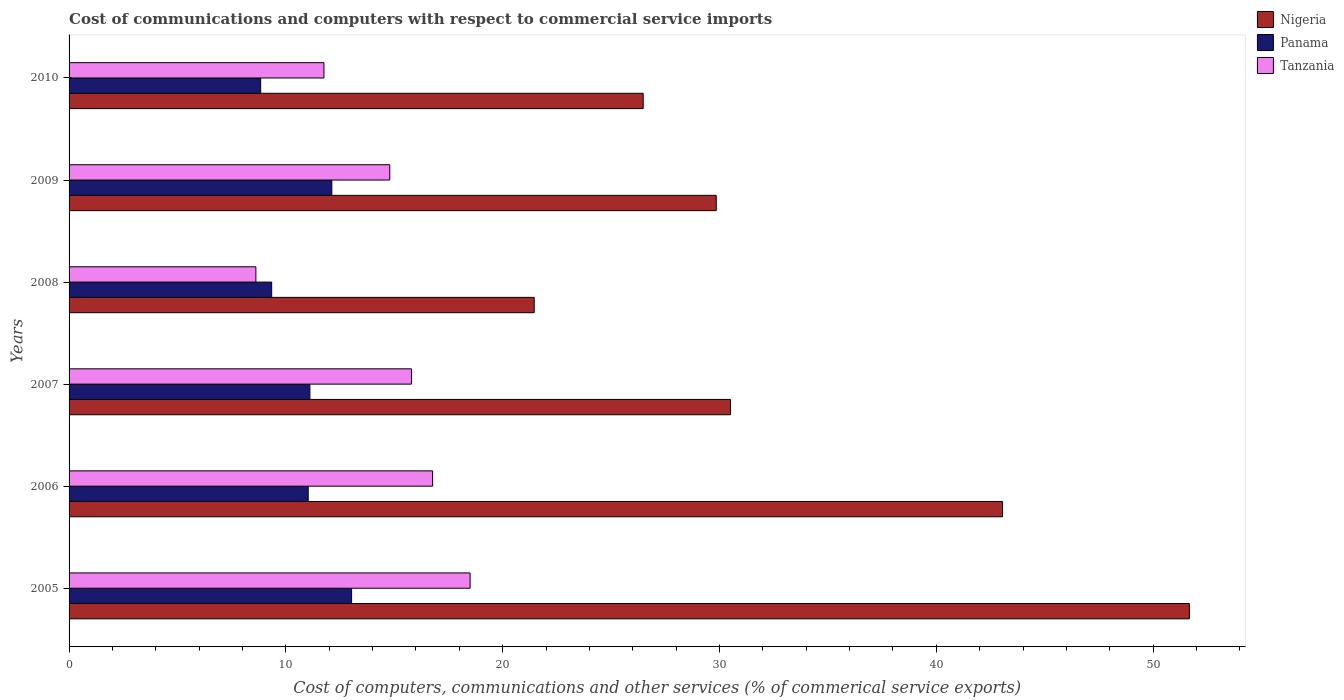How many different coloured bars are there?
Ensure brevity in your answer.  3. How many groups of bars are there?
Your response must be concise. 6. Are the number of bars per tick equal to the number of legend labels?
Provide a short and direct response. Yes. Are the number of bars on each tick of the Y-axis equal?
Make the answer very short. Yes. How many bars are there on the 6th tick from the top?
Your answer should be very brief. 3. How many bars are there on the 3rd tick from the bottom?
Make the answer very short. 3. What is the label of the 3rd group of bars from the top?
Your response must be concise. 2008. What is the cost of communications and computers in Panama in 2008?
Provide a short and direct response. 9.34. Across all years, what is the maximum cost of communications and computers in Tanzania?
Make the answer very short. 18.5. Across all years, what is the minimum cost of communications and computers in Nigeria?
Give a very brief answer. 21.45. In which year was the cost of communications and computers in Panama maximum?
Offer a very short reply. 2005. What is the total cost of communications and computers in Tanzania in the graph?
Give a very brief answer. 86.22. What is the difference between the cost of communications and computers in Panama in 2005 and that in 2007?
Make the answer very short. 1.92. What is the difference between the cost of communications and computers in Tanzania in 2006 and the cost of communications and computers in Panama in 2007?
Give a very brief answer. 5.66. What is the average cost of communications and computers in Nigeria per year?
Your answer should be very brief. 33.83. In the year 2007, what is the difference between the cost of communications and computers in Panama and cost of communications and computers in Nigeria?
Your response must be concise. -19.4. In how many years, is the cost of communications and computers in Panama greater than 20 %?
Give a very brief answer. 0. What is the ratio of the cost of communications and computers in Tanzania in 2006 to that in 2008?
Provide a succinct answer. 1.95. Is the difference between the cost of communications and computers in Panama in 2007 and 2010 greater than the difference between the cost of communications and computers in Nigeria in 2007 and 2010?
Provide a succinct answer. No. What is the difference between the highest and the second highest cost of communications and computers in Nigeria?
Your answer should be very brief. 8.62. What is the difference between the highest and the lowest cost of communications and computers in Panama?
Make the answer very short. 4.19. Is the sum of the cost of communications and computers in Nigeria in 2008 and 2010 greater than the maximum cost of communications and computers in Panama across all years?
Offer a terse response. Yes. What does the 3rd bar from the top in 2005 represents?
Offer a terse response. Nigeria. What does the 2nd bar from the bottom in 2007 represents?
Provide a short and direct response. Panama. Is it the case that in every year, the sum of the cost of communications and computers in Tanzania and cost of communications and computers in Panama is greater than the cost of communications and computers in Nigeria?
Ensure brevity in your answer.  No. How many bars are there?
Make the answer very short. 18. Are all the bars in the graph horizontal?
Provide a short and direct response. Yes. What is the difference between two consecutive major ticks on the X-axis?
Offer a terse response. 10. How are the legend labels stacked?
Provide a succinct answer. Vertical. What is the title of the graph?
Provide a succinct answer. Cost of communications and computers with respect to commercial service imports. What is the label or title of the X-axis?
Your answer should be very brief. Cost of computers, communications and other services (% of commerical service exports). What is the label or title of the Y-axis?
Your answer should be very brief. Years. What is the Cost of computers, communications and other services (% of commerical service exports) in Nigeria in 2005?
Provide a short and direct response. 51.67. What is the Cost of computers, communications and other services (% of commerical service exports) in Panama in 2005?
Provide a succinct answer. 13.03. What is the Cost of computers, communications and other services (% of commerical service exports) of Tanzania in 2005?
Your answer should be very brief. 18.5. What is the Cost of computers, communications and other services (% of commerical service exports) in Nigeria in 2006?
Keep it short and to the point. 43.05. What is the Cost of computers, communications and other services (% of commerical service exports) of Panama in 2006?
Keep it short and to the point. 11.03. What is the Cost of computers, communications and other services (% of commerical service exports) in Tanzania in 2006?
Give a very brief answer. 16.77. What is the Cost of computers, communications and other services (% of commerical service exports) in Nigeria in 2007?
Provide a short and direct response. 30.5. What is the Cost of computers, communications and other services (% of commerical service exports) of Panama in 2007?
Provide a succinct answer. 11.11. What is the Cost of computers, communications and other services (% of commerical service exports) of Tanzania in 2007?
Make the answer very short. 15.79. What is the Cost of computers, communications and other services (% of commerical service exports) of Nigeria in 2008?
Your answer should be compact. 21.45. What is the Cost of computers, communications and other services (% of commerical service exports) in Panama in 2008?
Your answer should be very brief. 9.34. What is the Cost of computers, communications and other services (% of commerical service exports) of Tanzania in 2008?
Your answer should be very brief. 8.62. What is the Cost of computers, communications and other services (% of commerical service exports) in Nigeria in 2009?
Your answer should be very brief. 29.85. What is the Cost of computers, communications and other services (% of commerical service exports) in Panama in 2009?
Your response must be concise. 12.12. What is the Cost of computers, communications and other services (% of commerical service exports) in Tanzania in 2009?
Your response must be concise. 14.79. What is the Cost of computers, communications and other services (% of commerical service exports) of Nigeria in 2010?
Provide a succinct answer. 26.48. What is the Cost of computers, communications and other services (% of commerical service exports) in Panama in 2010?
Your answer should be compact. 8.84. What is the Cost of computers, communications and other services (% of commerical service exports) of Tanzania in 2010?
Your answer should be compact. 11.76. Across all years, what is the maximum Cost of computers, communications and other services (% of commerical service exports) of Nigeria?
Keep it short and to the point. 51.67. Across all years, what is the maximum Cost of computers, communications and other services (% of commerical service exports) in Panama?
Your response must be concise. 13.03. Across all years, what is the maximum Cost of computers, communications and other services (% of commerical service exports) of Tanzania?
Your answer should be compact. 18.5. Across all years, what is the minimum Cost of computers, communications and other services (% of commerical service exports) in Nigeria?
Your response must be concise. 21.45. Across all years, what is the minimum Cost of computers, communications and other services (% of commerical service exports) of Panama?
Keep it short and to the point. 8.84. Across all years, what is the minimum Cost of computers, communications and other services (% of commerical service exports) in Tanzania?
Offer a terse response. 8.62. What is the total Cost of computers, communications and other services (% of commerical service exports) of Nigeria in the graph?
Provide a short and direct response. 203.01. What is the total Cost of computers, communications and other services (% of commerical service exports) in Panama in the graph?
Ensure brevity in your answer.  65.47. What is the total Cost of computers, communications and other services (% of commerical service exports) of Tanzania in the graph?
Offer a terse response. 86.22. What is the difference between the Cost of computers, communications and other services (% of commerical service exports) in Nigeria in 2005 and that in 2006?
Keep it short and to the point. 8.62. What is the difference between the Cost of computers, communications and other services (% of commerical service exports) in Panama in 2005 and that in 2006?
Make the answer very short. 2. What is the difference between the Cost of computers, communications and other services (% of commerical service exports) of Tanzania in 2005 and that in 2006?
Offer a terse response. 1.73. What is the difference between the Cost of computers, communications and other services (% of commerical service exports) in Nigeria in 2005 and that in 2007?
Make the answer very short. 21.17. What is the difference between the Cost of computers, communications and other services (% of commerical service exports) in Panama in 2005 and that in 2007?
Keep it short and to the point. 1.92. What is the difference between the Cost of computers, communications and other services (% of commerical service exports) in Tanzania in 2005 and that in 2007?
Ensure brevity in your answer.  2.7. What is the difference between the Cost of computers, communications and other services (% of commerical service exports) in Nigeria in 2005 and that in 2008?
Provide a succinct answer. 30.22. What is the difference between the Cost of computers, communications and other services (% of commerical service exports) of Panama in 2005 and that in 2008?
Give a very brief answer. 3.69. What is the difference between the Cost of computers, communications and other services (% of commerical service exports) of Tanzania in 2005 and that in 2008?
Give a very brief answer. 9.88. What is the difference between the Cost of computers, communications and other services (% of commerical service exports) in Nigeria in 2005 and that in 2009?
Offer a terse response. 21.82. What is the difference between the Cost of computers, communications and other services (% of commerical service exports) of Panama in 2005 and that in 2009?
Give a very brief answer. 0.91. What is the difference between the Cost of computers, communications and other services (% of commerical service exports) of Tanzania in 2005 and that in 2009?
Ensure brevity in your answer.  3.71. What is the difference between the Cost of computers, communications and other services (% of commerical service exports) in Nigeria in 2005 and that in 2010?
Your answer should be compact. 25.19. What is the difference between the Cost of computers, communications and other services (% of commerical service exports) of Panama in 2005 and that in 2010?
Offer a very short reply. 4.19. What is the difference between the Cost of computers, communications and other services (% of commerical service exports) of Tanzania in 2005 and that in 2010?
Your answer should be very brief. 6.74. What is the difference between the Cost of computers, communications and other services (% of commerical service exports) in Nigeria in 2006 and that in 2007?
Your answer should be very brief. 12.55. What is the difference between the Cost of computers, communications and other services (% of commerical service exports) of Panama in 2006 and that in 2007?
Offer a very short reply. -0.08. What is the difference between the Cost of computers, communications and other services (% of commerical service exports) of Tanzania in 2006 and that in 2007?
Offer a very short reply. 0.98. What is the difference between the Cost of computers, communications and other services (% of commerical service exports) in Nigeria in 2006 and that in 2008?
Ensure brevity in your answer.  21.6. What is the difference between the Cost of computers, communications and other services (% of commerical service exports) of Panama in 2006 and that in 2008?
Provide a short and direct response. 1.69. What is the difference between the Cost of computers, communications and other services (% of commerical service exports) in Tanzania in 2006 and that in 2008?
Ensure brevity in your answer.  8.15. What is the difference between the Cost of computers, communications and other services (% of commerical service exports) in Nigeria in 2006 and that in 2009?
Offer a terse response. 13.2. What is the difference between the Cost of computers, communications and other services (% of commerical service exports) of Panama in 2006 and that in 2009?
Your response must be concise. -1.09. What is the difference between the Cost of computers, communications and other services (% of commerical service exports) in Tanzania in 2006 and that in 2009?
Provide a short and direct response. 1.98. What is the difference between the Cost of computers, communications and other services (% of commerical service exports) in Nigeria in 2006 and that in 2010?
Keep it short and to the point. 16.57. What is the difference between the Cost of computers, communications and other services (% of commerical service exports) of Panama in 2006 and that in 2010?
Your answer should be very brief. 2.19. What is the difference between the Cost of computers, communications and other services (% of commerical service exports) of Tanzania in 2006 and that in 2010?
Ensure brevity in your answer.  5.01. What is the difference between the Cost of computers, communications and other services (% of commerical service exports) of Nigeria in 2007 and that in 2008?
Provide a short and direct response. 9.05. What is the difference between the Cost of computers, communications and other services (% of commerical service exports) in Panama in 2007 and that in 2008?
Make the answer very short. 1.76. What is the difference between the Cost of computers, communications and other services (% of commerical service exports) in Tanzania in 2007 and that in 2008?
Offer a terse response. 7.18. What is the difference between the Cost of computers, communications and other services (% of commerical service exports) in Nigeria in 2007 and that in 2009?
Give a very brief answer. 0.66. What is the difference between the Cost of computers, communications and other services (% of commerical service exports) in Panama in 2007 and that in 2009?
Ensure brevity in your answer.  -1.01. What is the difference between the Cost of computers, communications and other services (% of commerical service exports) in Tanzania in 2007 and that in 2009?
Ensure brevity in your answer.  1. What is the difference between the Cost of computers, communications and other services (% of commerical service exports) of Nigeria in 2007 and that in 2010?
Ensure brevity in your answer.  4.02. What is the difference between the Cost of computers, communications and other services (% of commerical service exports) of Panama in 2007 and that in 2010?
Offer a terse response. 2.27. What is the difference between the Cost of computers, communications and other services (% of commerical service exports) of Tanzania in 2007 and that in 2010?
Offer a terse response. 4.04. What is the difference between the Cost of computers, communications and other services (% of commerical service exports) of Nigeria in 2008 and that in 2009?
Offer a terse response. -8.4. What is the difference between the Cost of computers, communications and other services (% of commerical service exports) in Panama in 2008 and that in 2009?
Ensure brevity in your answer.  -2.78. What is the difference between the Cost of computers, communications and other services (% of commerical service exports) in Tanzania in 2008 and that in 2009?
Make the answer very short. -6.17. What is the difference between the Cost of computers, communications and other services (% of commerical service exports) in Nigeria in 2008 and that in 2010?
Your answer should be compact. -5.03. What is the difference between the Cost of computers, communications and other services (% of commerical service exports) in Panama in 2008 and that in 2010?
Your answer should be compact. 0.51. What is the difference between the Cost of computers, communications and other services (% of commerical service exports) in Tanzania in 2008 and that in 2010?
Give a very brief answer. -3.14. What is the difference between the Cost of computers, communications and other services (% of commerical service exports) of Nigeria in 2009 and that in 2010?
Provide a short and direct response. 3.37. What is the difference between the Cost of computers, communications and other services (% of commerical service exports) of Panama in 2009 and that in 2010?
Offer a terse response. 3.28. What is the difference between the Cost of computers, communications and other services (% of commerical service exports) in Tanzania in 2009 and that in 2010?
Your response must be concise. 3.04. What is the difference between the Cost of computers, communications and other services (% of commerical service exports) in Nigeria in 2005 and the Cost of computers, communications and other services (% of commerical service exports) in Panama in 2006?
Provide a succinct answer. 40.64. What is the difference between the Cost of computers, communications and other services (% of commerical service exports) in Nigeria in 2005 and the Cost of computers, communications and other services (% of commerical service exports) in Tanzania in 2006?
Provide a short and direct response. 34.9. What is the difference between the Cost of computers, communications and other services (% of commerical service exports) of Panama in 2005 and the Cost of computers, communications and other services (% of commerical service exports) of Tanzania in 2006?
Ensure brevity in your answer.  -3.74. What is the difference between the Cost of computers, communications and other services (% of commerical service exports) of Nigeria in 2005 and the Cost of computers, communications and other services (% of commerical service exports) of Panama in 2007?
Offer a very short reply. 40.57. What is the difference between the Cost of computers, communications and other services (% of commerical service exports) in Nigeria in 2005 and the Cost of computers, communications and other services (% of commerical service exports) in Tanzania in 2007?
Make the answer very short. 35.88. What is the difference between the Cost of computers, communications and other services (% of commerical service exports) of Panama in 2005 and the Cost of computers, communications and other services (% of commerical service exports) of Tanzania in 2007?
Provide a short and direct response. -2.76. What is the difference between the Cost of computers, communications and other services (% of commerical service exports) of Nigeria in 2005 and the Cost of computers, communications and other services (% of commerical service exports) of Panama in 2008?
Your answer should be compact. 42.33. What is the difference between the Cost of computers, communications and other services (% of commerical service exports) in Nigeria in 2005 and the Cost of computers, communications and other services (% of commerical service exports) in Tanzania in 2008?
Provide a short and direct response. 43.06. What is the difference between the Cost of computers, communications and other services (% of commerical service exports) in Panama in 2005 and the Cost of computers, communications and other services (% of commerical service exports) in Tanzania in 2008?
Provide a short and direct response. 4.42. What is the difference between the Cost of computers, communications and other services (% of commerical service exports) of Nigeria in 2005 and the Cost of computers, communications and other services (% of commerical service exports) of Panama in 2009?
Provide a short and direct response. 39.55. What is the difference between the Cost of computers, communications and other services (% of commerical service exports) in Nigeria in 2005 and the Cost of computers, communications and other services (% of commerical service exports) in Tanzania in 2009?
Your answer should be very brief. 36.88. What is the difference between the Cost of computers, communications and other services (% of commerical service exports) in Panama in 2005 and the Cost of computers, communications and other services (% of commerical service exports) in Tanzania in 2009?
Your response must be concise. -1.76. What is the difference between the Cost of computers, communications and other services (% of commerical service exports) of Nigeria in 2005 and the Cost of computers, communications and other services (% of commerical service exports) of Panama in 2010?
Provide a succinct answer. 42.83. What is the difference between the Cost of computers, communications and other services (% of commerical service exports) in Nigeria in 2005 and the Cost of computers, communications and other services (% of commerical service exports) in Tanzania in 2010?
Provide a short and direct response. 39.92. What is the difference between the Cost of computers, communications and other services (% of commerical service exports) in Panama in 2005 and the Cost of computers, communications and other services (% of commerical service exports) in Tanzania in 2010?
Your answer should be very brief. 1.28. What is the difference between the Cost of computers, communications and other services (% of commerical service exports) of Nigeria in 2006 and the Cost of computers, communications and other services (% of commerical service exports) of Panama in 2007?
Your response must be concise. 31.94. What is the difference between the Cost of computers, communications and other services (% of commerical service exports) in Nigeria in 2006 and the Cost of computers, communications and other services (% of commerical service exports) in Tanzania in 2007?
Give a very brief answer. 27.26. What is the difference between the Cost of computers, communications and other services (% of commerical service exports) of Panama in 2006 and the Cost of computers, communications and other services (% of commerical service exports) of Tanzania in 2007?
Your answer should be very brief. -4.76. What is the difference between the Cost of computers, communications and other services (% of commerical service exports) in Nigeria in 2006 and the Cost of computers, communications and other services (% of commerical service exports) in Panama in 2008?
Provide a short and direct response. 33.71. What is the difference between the Cost of computers, communications and other services (% of commerical service exports) in Nigeria in 2006 and the Cost of computers, communications and other services (% of commerical service exports) in Tanzania in 2008?
Keep it short and to the point. 34.43. What is the difference between the Cost of computers, communications and other services (% of commerical service exports) in Panama in 2006 and the Cost of computers, communications and other services (% of commerical service exports) in Tanzania in 2008?
Offer a terse response. 2.41. What is the difference between the Cost of computers, communications and other services (% of commerical service exports) in Nigeria in 2006 and the Cost of computers, communications and other services (% of commerical service exports) in Panama in 2009?
Give a very brief answer. 30.93. What is the difference between the Cost of computers, communications and other services (% of commerical service exports) in Nigeria in 2006 and the Cost of computers, communications and other services (% of commerical service exports) in Tanzania in 2009?
Provide a succinct answer. 28.26. What is the difference between the Cost of computers, communications and other services (% of commerical service exports) of Panama in 2006 and the Cost of computers, communications and other services (% of commerical service exports) of Tanzania in 2009?
Your answer should be compact. -3.76. What is the difference between the Cost of computers, communications and other services (% of commerical service exports) of Nigeria in 2006 and the Cost of computers, communications and other services (% of commerical service exports) of Panama in 2010?
Provide a short and direct response. 34.21. What is the difference between the Cost of computers, communications and other services (% of commerical service exports) in Nigeria in 2006 and the Cost of computers, communications and other services (% of commerical service exports) in Tanzania in 2010?
Provide a succinct answer. 31.3. What is the difference between the Cost of computers, communications and other services (% of commerical service exports) of Panama in 2006 and the Cost of computers, communications and other services (% of commerical service exports) of Tanzania in 2010?
Ensure brevity in your answer.  -0.73. What is the difference between the Cost of computers, communications and other services (% of commerical service exports) in Nigeria in 2007 and the Cost of computers, communications and other services (% of commerical service exports) in Panama in 2008?
Offer a terse response. 21.16. What is the difference between the Cost of computers, communications and other services (% of commerical service exports) of Nigeria in 2007 and the Cost of computers, communications and other services (% of commerical service exports) of Tanzania in 2008?
Give a very brief answer. 21.89. What is the difference between the Cost of computers, communications and other services (% of commerical service exports) in Panama in 2007 and the Cost of computers, communications and other services (% of commerical service exports) in Tanzania in 2008?
Your answer should be compact. 2.49. What is the difference between the Cost of computers, communications and other services (% of commerical service exports) of Nigeria in 2007 and the Cost of computers, communications and other services (% of commerical service exports) of Panama in 2009?
Offer a terse response. 18.38. What is the difference between the Cost of computers, communications and other services (% of commerical service exports) of Nigeria in 2007 and the Cost of computers, communications and other services (% of commerical service exports) of Tanzania in 2009?
Ensure brevity in your answer.  15.71. What is the difference between the Cost of computers, communications and other services (% of commerical service exports) of Panama in 2007 and the Cost of computers, communications and other services (% of commerical service exports) of Tanzania in 2009?
Offer a very short reply. -3.68. What is the difference between the Cost of computers, communications and other services (% of commerical service exports) in Nigeria in 2007 and the Cost of computers, communications and other services (% of commerical service exports) in Panama in 2010?
Provide a short and direct response. 21.67. What is the difference between the Cost of computers, communications and other services (% of commerical service exports) in Nigeria in 2007 and the Cost of computers, communications and other services (% of commerical service exports) in Tanzania in 2010?
Offer a very short reply. 18.75. What is the difference between the Cost of computers, communications and other services (% of commerical service exports) of Panama in 2007 and the Cost of computers, communications and other services (% of commerical service exports) of Tanzania in 2010?
Give a very brief answer. -0.65. What is the difference between the Cost of computers, communications and other services (% of commerical service exports) in Nigeria in 2008 and the Cost of computers, communications and other services (% of commerical service exports) in Panama in 2009?
Your answer should be very brief. 9.33. What is the difference between the Cost of computers, communications and other services (% of commerical service exports) in Nigeria in 2008 and the Cost of computers, communications and other services (% of commerical service exports) in Tanzania in 2009?
Offer a terse response. 6.66. What is the difference between the Cost of computers, communications and other services (% of commerical service exports) in Panama in 2008 and the Cost of computers, communications and other services (% of commerical service exports) in Tanzania in 2009?
Provide a succinct answer. -5.45. What is the difference between the Cost of computers, communications and other services (% of commerical service exports) in Nigeria in 2008 and the Cost of computers, communications and other services (% of commerical service exports) in Panama in 2010?
Your answer should be compact. 12.62. What is the difference between the Cost of computers, communications and other services (% of commerical service exports) in Nigeria in 2008 and the Cost of computers, communications and other services (% of commerical service exports) in Tanzania in 2010?
Offer a very short reply. 9.7. What is the difference between the Cost of computers, communications and other services (% of commerical service exports) of Panama in 2008 and the Cost of computers, communications and other services (% of commerical service exports) of Tanzania in 2010?
Make the answer very short. -2.41. What is the difference between the Cost of computers, communications and other services (% of commerical service exports) of Nigeria in 2009 and the Cost of computers, communications and other services (% of commerical service exports) of Panama in 2010?
Offer a very short reply. 21.01. What is the difference between the Cost of computers, communications and other services (% of commerical service exports) in Nigeria in 2009 and the Cost of computers, communications and other services (% of commerical service exports) in Tanzania in 2010?
Give a very brief answer. 18.09. What is the difference between the Cost of computers, communications and other services (% of commerical service exports) in Panama in 2009 and the Cost of computers, communications and other services (% of commerical service exports) in Tanzania in 2010?
Offer a very short reply. 0.36. What is the average Cost of computers, communications and other services (% of commerical service exports) in Nigeria per year?
Your response must be concise. 33.83. What is the average Cost of computers, communications and other services (% of commerical service exports) of Panama per year?
Ensure brevity in your answer.  10.91. What is the average Cost of computers, communications and other services (% of commerical service exports) of Tanzania per year?
Provide a short and direct response. 14.37. In the year 2005, what is the difference between the Cost of computers, communications and other services (% of commerical service exports) in Nigeria and Cost of computers, communications and other services (% of commerical service exports) in Panama?
Your answer should be compact. 38.64. In the year 2005, what is the difference between the Cost of computers, communications and other services (% of commerical service exports) of Nigeria and Cost of computers, communications and other services (% of commerical service exports) of Tanzania?
Offer a very short reply. 33.18. In the year 2005, what is the difference between the Cost of computers, communications and other services (% of commerical service exports) of Panama and Cost of computers, communications and other services (% of commerical service exports) of Tanzania?
Offer a very short reply. -5.46. In the year 2006, what is the difference between the Cost of computers, communications and other services (% of commerical service exports) of Nigeria and Cost of computers, communications and other services (% of commerical service exports) of Panama?
Provide a succinct answer. 32.02. In the year 2006, what is the difference between the Cost of computers, communications and other services (% of commerical service exports) in Nigeria and Cost of computers, communications and other services (% of commerical service exports) in Tanzania?
Ensure brevity in your answer.  26.28. In the year 2006, what is the difference between the Cost of computers, communications and other services (% of commerical service exports) in Panama and Cost of computers, communications and other services (% of commerical service exports) in Tanzania?
Ensure brevity in your answer.  -5.74. In the year 2007, what is the difference between the Cost of computers, communications and other services (% of commerical service exports) in Nigeria and Cost of computers, communications and other services (% of commerical service exports) in Panama?
Keep it short and to the point. 19.4. In the year 2007, what is the difference between the Cost of computers, communications and other services (% of commerical service exports) in Nigeria and Cost of computers, communications and other services (% of commerical service exports) in Tanzania?
Your response must be concise. 14.71. In the year 2007, what is the difference between the Cost of computers, communications and other services (% of commerical service exports) in Panama and Cost of computers, communications and other services (% of commerical service exports) in Tanzania?
Provide a succinct answer. -4.69. In the year 2008, what is the difference between the Cost of computers, communications and other services (% of commerical service exports) of Nigeria and Cost of computers, communications and other services (% of commerical service exports) of Panama?
Provide a succinct answer. 12.11. In the year 2008, what is the difference between the Cost of computers, communications and other services (% of commerical service exports) in Nigeria and Cost of computers, communications and other services (% of commerical service exports) in Tanzania?
Make the answer very short. 12.84. In the year 2008, what is the difference between the Cost of computers, communications and other services (% of commerical service exports) in Panama and Cost of computers, communications and other services (% of commerical service exports) in Tanzania?
Make the answer very short. 0.73. In the year 2009, what is the difference between the Cost of computers, communications and other services (% of commerical service exports) in Nigeria and Cost of computers, communications and other services (% of commerical service exports) in Panama?
Your answer should be compact. 17.73. In the year 2009, what is the difference between the Cost of computers, communications and other services (% of commerical service exports) in Nigeria and Cost of computers, communications and other services (% of commerical service exports) in Tanzania?
Offer a terse response. 15.06. In the year 2009, what is the difference between the Cost of computers, communications and other services (% of commerical service exports) in Panama and Cost of computers, communications and other services (% of commerical service exports) in Tanzania?
Your answer should be very brief. -2.67. In the year 2010, what is the difference between the Cost of computers, communications and other services (% of commerical service exports) of Nigeria and Cost of computers, communications and other services (% of commerical service exports) of Panama?
Ensure brevity in your answer.  17.64. In the year 2010, what is the difference between the Cost of computers, communications and other services (% of commerical service exports) in Nigeria and Cost of computers, communications and other services (% of commerical service exports) in Tanzania?
Provide a succinct answer. 14.72. In the year 2010, what is the difference between the Cost of computers, communications and other services (% of commerical service exports) of Panama and Cost of computers, communications and other services (% of commerical service exports) of Tanzania?
Your answer should be compact. -2.92. What is the ratio of the Cost of computers, communications and other services (% of commerical service exports) in Nigeria in 2005 to that in 2006?
Provide a short and direct response. 1.2. What is the ratio of the Cost of computers, communications and other services (% of commerical service exports) of Panama in 2005 to that in 2006?
Keep it short and to the point. 1.18. What is the ratio of the Cost of computers, communications and other services (% of commerical service exports) in Tanzania in 2005 to that in 2006?
Give a very brief answer. 1.1. What is the ratio of the Cost of computers, communications and other services (% of commerical service exports) of Nigeria in 2005 to that in 2007?
Your answer should be compact. 1.69. What is the ratio of the Cost of computers, communications and other services (% of commerical service exports) of Panama in 2005 to that in 2007?
Provide a succinct answer. 1.17. What is the ratio of the Cost of computers, communications and other services (% of commerical service exports) of Tanzania in 2005 to that in 2007?
Ensure brevity in your answer.  1.17. What is the ratio of the Cost of computers, communications and other services (% of commerical service exports) in Nigeria in 2005 to that in 2008?
Your answer should be compact. 2.41. What is the ratio of the Cost of computers, communications and other services (% of commerical service exports) in Panama in 2005 to that in 2008?
Make the answer very short. 1.39. What is the ratio of the Cost of computers, communications and other services (% of commerical service exports) in Tanzania in 2005 to that in 2008?
Ensure brevity in your answer.  2.15. What is the ratio of the Cost of computers, communications and other services (% of commerical service exports) in Nigeria in 2005 to that in 2009?
Keep it short and to the point. 1.73. What is the ratio of the Cost of computers, communications and other services (% of commerical service exports) of Panama in 2005 to that in 2009?
Your answer should be very brief. 1.08. What is the ratio of the Cost of computers, communications and other services (% of commerical service exports) of Tanzania in 2005 to that in 2009?
Your response must be concise. 1.25. What is the ratio of the Cost of computers, communications and other services (% of commerical service exports) of Nigeria in 2005 to that in 2010?
Your response must be concise. 1.95. What is the ratio of the Cost of computers, communications and other services (% of commerical service exports) of Panama in 2005 to that in 2010?
Offer a terse response. 1.47. What is the ratio of the Cost of computers, communications and other services (% of commerical service exports) in Tanzania in 2005 to that in 2010?
Provide a succinct answer. 1.57. What is the ratio of the Cost of computers, communications and other services (% of commerical service exports) in Nigeria in 2006 to that in 2007?
Offer a very short reply. 1.41. What is the ratio of the Cost of computers, communications and other services (% of commerical service exports) in Tanzania in 2006 to that in 2007?
Offer a very short reply. 1.06. What is the ratio of the Cost of computers, communications and other services (% of commerical service exports) in Nigeria in 2006 to that in 2008?
Keep it short and to the point. 2.01. What is the ratio of the Cost of computers, communications and other services (% of commerical service exports) in Panama in 2006 to that in 2008?
Ensure brevity in your answer.  1.18. What is the ratio of the Cost of computers, communications and other services (% of commerical service exports) in Tanzania in 2006 to that in 2008?
Provide a short and direct response. 1.95. What is the ratio of the Cost of computers, communications and other services (% of commerical service exports) in Nigeria in 2006 to that in 2009?
Provide a succinct answer. 1.44. What is the ratio of the Cost of computers, communications and other services (% of commerical service exports) in Panama in 2006 to that in 2009?
Your response must be concise. 0.91. What is the ratio of the Cost of computers, communications and other services (% of commerical service exports) of Tanzania in 2006 to that in 2009?
Keep it short and to the point. 1.13. What is the ratio of the Cost of computers, communications and other services (% of commerical service exports) in Nigeria in 2006 to that in 2010?
Ensure brevity in your answer.  1.63. What is the ratio of the Cost of computers, communications and other services (% of commerical service exports) of Panama in 2006 to that in 2010?
Offer a very short reply. 1.25. What is the ratio of the Cost of computers, communications and other services (% of commerical service exports) in Tanzania in 2006 to that in 2010?
Keep it short and to the point. 1.43. What is the ratio of the Cost of computers, communications and other services (% of commerical service exports) of Nigeria in 2007 to that in 2008?
Offer a very short reply. 1.42. What is the ratio of the Cost of computers, communications and other services (% of commerical service exports) in Panama in 2007 to that in 2008?
Make the answer very short. 1.19. What is the ratio of the Cost of computers, communications and other services (% of commerical service exports) of Tanzania in 2007 to that in 2008?
Provide a short and direct response. 1.83. What is the ratio of the Cost of computers, communications and other services (% of commerical service exports) in Nigeria in 2007 to that in 2009?
Make the answer very short. 1.02. What is the ratio of the Cost of computers, communications and other services (% of commerical service exports) in Panama in 2007 to that in 2009?
Make the answer very short. 0.92. What is the ratio of the Cost of computers, communications and other services (% of commerical service exports) of Tanzania in 2007 to that in 2009?
Provide a short and direct response. 1.07. What is the ratio of the Cost of computers, communications and other services (% of commerical service exports) of Nigeria in 2007 to that in 2010?
Offer a very short reply. 1.15. What is the ratio of the Cost of computers, communications and other services (% of commerical service exports) of Panama in 2007 to that in 2010?
Your answer should be compact. 1.26. What is the ratio of the Cost of computers, communications and other services (% of commerical service exports) of Tanzania in 2007 to that in 2010?
Ensure brevity in your answer.  1.34. What is the ratio of the Cost of computers, communications and other services (% of commerical service exports) of Nigeria in 2008 to that in 2009?
Keep it short and to the point. 0.72. What is the ratio of the Cost of computers, communications and other services (% of commerical service exports) of Panama in 2008 to that in 2009?
Offer a terse response. 0.77. What is the ratio of the Cost of computers, communications and other services (% of commerical service exports) of Tanzania in 2008 to that in 2009?
Provide a short and direct response. 0.58. What is the ratio of the Cost of computers, communications and other services (% of commerical service exports) of Nigeria in 2008 to that in 2010?
Offer a terse response. 0.81. What is the ratio of the Cost of computers, communications and other services (% of commerical service exports) of Panama in 2008 to that in 2010?
Your response must be concise. 1.06. What is the ratio of the Cost of computers, communications and other services (% of commerical service exports) in Tanzania in 2008 to that in 2010?
Offer a very short reply. 0.73. What is the ratio of the Cost of computers, communications and other services (% of commerical service exports) in Nigeria in 2009 to that in 2010?
Offer a very short reply. 1.13. What is the ratio of the Cost of computers, communications and other services (% of commerical service exports) in Panama in 2009 to that in 2010?
Ensure brevity in your answer.  1.37. What is the ratio of the Cost of computers, communications and other services (% of commerical service exports) in Tanzania in 2009 to that in 2010?
Keep it short and to the point. 1.26. What is the difference between the highest and the second highest Cost of computers, communications and other services (% of commerical service exports) of Nigeria?
Provide a short and direct response. 8.62. What is the difference between the highest and the second highest Cost of computers, communications and other services (% of commerical service exports) of Panama?
Your response must be concise. 0.91. What is the difference between the highest and the second highest Cost of computers, communications and other services (% of commerical service exports) in Tanzania?
Make the answer very short. 1.73. What is the difference between the highest and the lowest Cost of computers, communications and other services (% of commerical service exports) of Nigeria?
Provide a succinct answer. 30.22. What is the difference between the highest and the lowest Cost of computers, communications and other services (% of commerical service exports) of Panama?
Offer a very short reply. 4.19. What is the difference between the highest and the lowest Cost of computers, communications and other services (% of commerical service exports) in Tanzania?
Provide a succinct answer. 9.88. 